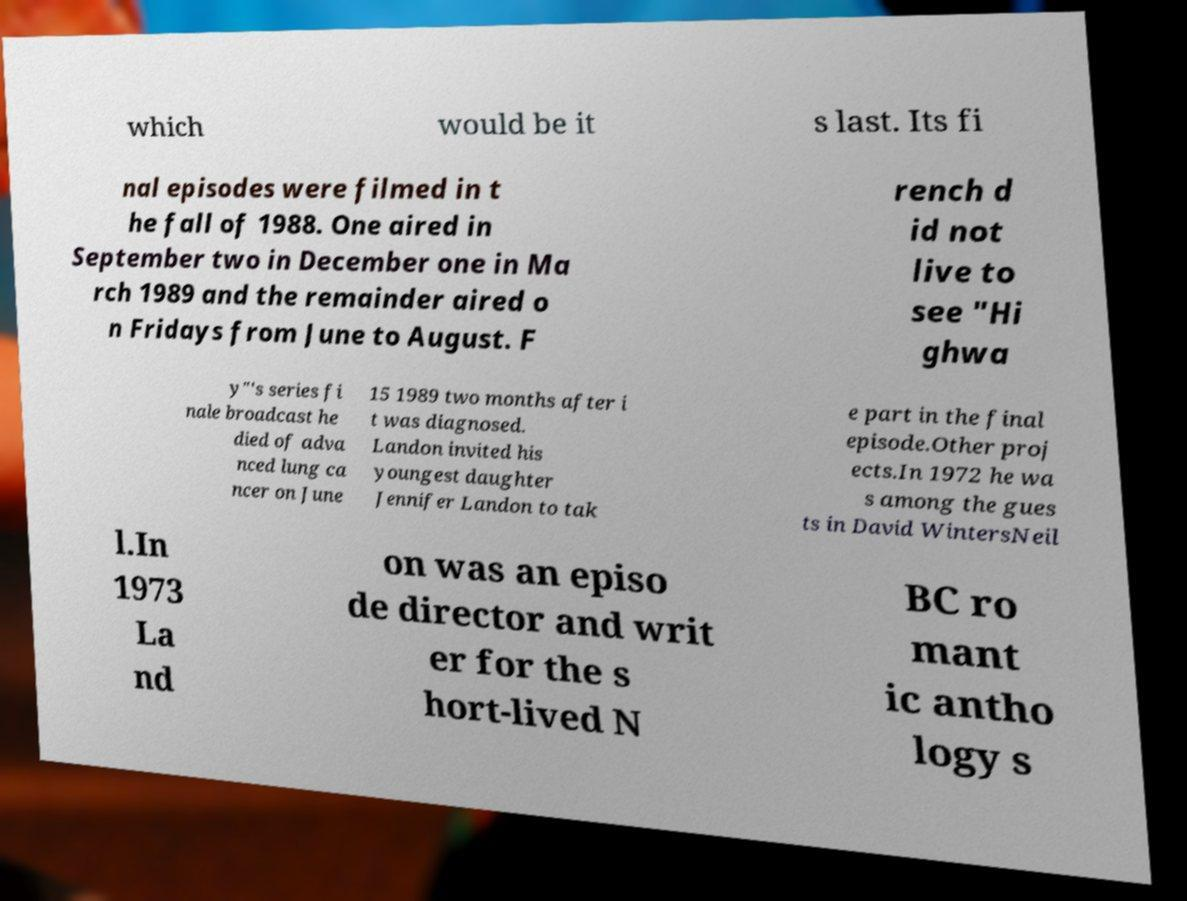There's text embedded in this image that I need extracted. Can you transcribe it verbatim? which would be it s last. Its fi nal episodes were filmed in t he fall of 1988. One aired in September two in December one in Ma rch 1989 and the remainder aired o n Fridays from June to August. F rench d id not live to see "Hi ghwa y"'s series fi nale broadcast he died of adva nced lung ca ncer on June 15 1989 two months after i t was diagnosed. Landon invited his youngest daughter Jennifer Landon to tak e part in the final episode.Other proj ects.In 1972 he wa s among the gues ts in David WintersNeil l.In 1973 La nd on was an episo de director and writ er for the s hort-lived N BC ro mant ic antho logy s 